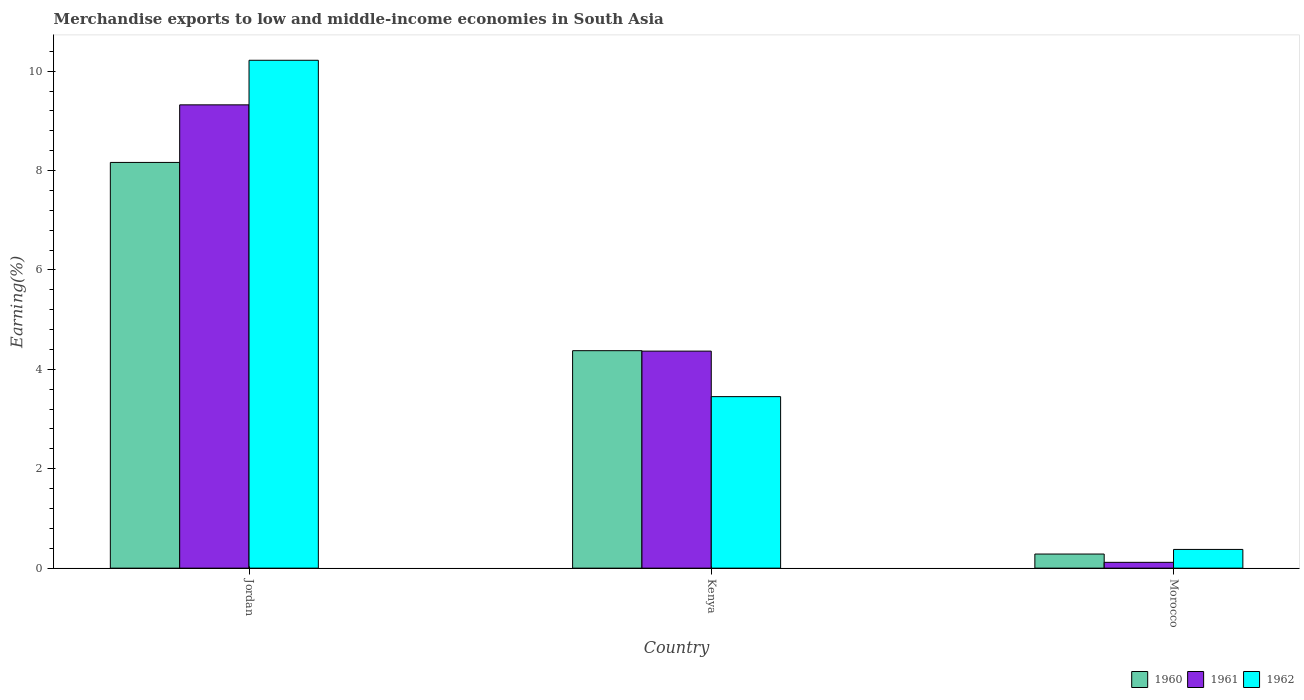How many bars are there on the 1st tick from the right?
Offer a very short reply. 3. What is the label of the 2nd group of bars from the left?
Offer a terse response. Kenya. In how many cases, is the number of bars for a given country not equal to the number of legend labels?
Keep it short and to the point. 0. What is the percentage of amount earned from merchandise exports in 1961 in Jordan?
Give a very brief answer. 9.32. Across all countries, what is the maximum percentage of amount earned from merchandise exports in 1962?
Your answer should be very brief. 10.22. Across all countries, what is the minimum percentage of amount earned from merchandise exports in 1961?
Your answer should be compact. 0.12. In which country was the percentage of amount earned from merchandise exports in 1962 maximum?
Your answer should be very brief. Jordan. In which country was the percentage of amount earned from merchandise exports in 1961 minimum?
Ensure brevity in your answer.  Morocco. What is the total percentage of amount earned from merchandise exports in 1961 in the graph?
Ensure brevity in your answer.  13.81. What is the difference between the percentage of amount earned from merchandise exports in 1961 in Kenya and that in Morocco?
Your response must be concise. 4.25. What is the difference between the percentage of amount earned from merchandise exports in 1960 in Jordan and the percentage of amount earned from merchandise exports in 1961 in Kenya?
Keep it short and to the point. 3.8. What is the average percentage of amount earned from merchandise exports in 1962 per country?
Provide a succinct answer. 4.68. What is the difference between the percentage of amount earned from merchandise exports of/in 1961 and percentage of amount earned from merchandise exports of/in 1962 in Jordan?
Keep it short and to the point. -0.9. What is the ratio of the percentage of amount earned from merchandise exports in 1962 in Jordan to that in Kenya?
Your answer should be compact. 2.96. Is the difference between the percentage of amount earned from merchandise exports in 1961 in Jordan and Morocco greater than the difference between the percentage of amount earned from merchandise exports in 1962 in Jordan and Morocco?
Your answer should be compact. No. What is the difference between the highest and the second highest percentage of amount earned from merchandise exports in 1961?
Give a very brief answer. -9.21. What is the difference between the highest and the lowest percentage of amount earned from merchandise exports in 1961?
Provide a succinct answer. 9.21. In how many countries, is the percentage of amount earned from merchandise exports in 1960 greater than the average percentage of amount earned from merchandise exports in 1960 taken over all countries?
Your answer should be compact. 2. What does the 1st bar from the left in Jordan represents?
Provide a short and direct response. 1960. Is it the case that in every country, the sum of the percentage of amount earned from merchandise exports in 1962 and percentage of amount earned from merchandise exports in 1960 is greater than the percentage of amount earned from merchandise exports in 1961?
Make the answer very short. Yes. Are the values on the major ticks of Y-axis written in scientific E-notation?
Ensure brevity in your answer.  No. What is the title of the graph?
Give a very brief answer. Merchandise exports to low and middle-income economies in South Asia. Does "1966" appear as one of the legend labels in the graph?
Keep it short and to the point. No. What is the label or title of the Y-axis?
Your response must be concise. Earning(%). What is the Earning(%) in 1960 in Jordan?
Your answer should be very brief. 8.16. What is the Earning(%) of 1961 in Jordan?
Offer a very short reply. 9.32. What is the Earning(%) of 1962 in Jordan?
Provide a short and direct response. 10.22. What is the Earning(%) in 1960 in Kenya?
Your answer should be compact. 4.38. What is the Earning(%) in 1961 in Kenya?
Provide a succinct answer. 4.37. What is the Earning(%) of 1962 in Kenya?
Your response must be concise. 3.45. What is the Earning(%) in 1960 in Morocco?
Make the answer very short. 0.28. What is the Earning(%) in 1961 in Morocco?
Provide a succinct answer. 0.12. What is the Earning(%) in 1962 in Morocco?
Make the answer very short. 0.38. Across all countries, what is the maximum Earning(%) in 1960?
Provide a succinct answer. 8.16. Across all countries, what is the maximum Earning(%) in 1961?
Your answer should be very brief. 9.32. Across all countries, what is the maximum Earning(%) in 1962?
Your answer should be very brief. 10.22. Across all countries, what is the minimum Earning(%) of 1960?
Keep it short and to the point. 0.28. Across all countries, what is the minimum Earning(%) in 1961?
Your response must be concise. 0.12. Across all countries, what is the minimum Earning(%) of 1962?
Provide a short and direct response. 0.38. What is the total Earning(%) in 1960 in the graph?
Keep it short and to the point. 12.82. What is the total Earning(%) of 1961 in the graph?
Give a very brief answer. 13.81. What is the total Earning(%) of 1962 in the graph?
Provide a short and direct response. 14.05. What is the difference between the Earning(%) in 1960 in Jordan and that in Kenya?
Provide a short and direct response. 3.79. What is the difference between the Earning(%) of 1961 in Jordan and that in Kenya?
Your response must be concise. 4.96. What is the difference between the Earning(%) in 1962 in Jordan and that in Kenya?
Keep it short and to the point. 6.77. What is the difference between the Earning(%) in 1960 in Jordan and that in Morocco?
Your answer should be very brief. 7.88. What is the difference between the Earning(%) in 1961 in Jordan and that in Morocco?
Give a very brief answer. 9.21. What is the difference between the Earning(%) of 1962 in Jordan and that in Morocco?
Offer a very short reply. 9.84. What is the difference between the Earning(%) of 1960 in Kenya and that in Morocco?
Offer a very short reply. 4.09. What is the difference between the Earning(%) of 1961 in Kenya and that in Morocco?
Offer a very short reply. 4.25. What is the difference between the Earning(%) in 1962 in Kenya and that in Morocco?
Offer a terse response. 3.07. What is the difference between the Earning(%) of 1960 in Jordan and the Earning(%) of 1961 in Kenya?
Your response must be concise. 3.8. What is the difference between the Earning(%) of 1960 in Jordan and the Earning(%) of 1962 in Kenya?
Your answer should be very brief. 4.71. What is the difference between the Earning(%) of 1961 in Jordan and the Earning(%) of 1962 in Kenya?
Give a very brief answer. 5.87. What is the difference between the Earning(%) of 1960 in Jordan and the Earning(%) of 1961 in Morocco?
Offer a terse response. 8.05. What is the difference between the Earning(%) in 1960 in Jordan and the Earning(%) in 1962 in Morocco?
Offer a terse response. 7.79. What is the difference between the Earning(%) in 1961 in Jordan and the Earning(%) in 1962 in Morocco?
Your answer should be compact. 8.95. What is the difference between the Earning(%) of 1960 in Kenya and the Earning(%) of 1961 in Morocco?
Make the answer very short. 4.26. What is the difference between the Earning(%) of 1960 in Kenya and the Earning(%) of 1962 in Morocco?
Your answer should be compact. 4. What is the difference between the Earning(%) in 1961 in Kenya and the Earning(%) in 1962 in Morocco?
Offer a terse response. 3.99. What is the average Earning(%) of 1960 per country?
Offer a very short reply. 4.27. What is the average Earning(%) in 1961 per country?
Your answer should be very brief. 4.6. What is the average Earning(%) of 1962 per country?
Ensure brevity in your answer.  4.68. What is the difference between the Earning(%) in 1960 and Earning(%) in 1961 in Jordan?
Provide a short and direct response. -1.16. What is the difference between the Earning(%) of 1960 and Earning(%) of 1962 in Jordan?
Your answer should be very brief. -2.06. What is the difference between the Earning(%) of 1961 and Earning(%) of 1962 in Jordan?
Ensure brevity in your answer.  -0.9. What is the difference between the Earning(%) in 1960 and Earning(%) in 1961 in Kenya?
Your answer should be compact. 0.01. What is the difference between the Earning(%) of 1960 and Earning(%) of 1962 in Kenya?
Keep it short and to the point. 0.92. What is the difference between the Earning(%) of 1961 and Earning(%) of 1962 in Kenya?
Your answer should be very brief. 0.92. What is the difference between the Earning(%) in 1960 and Earning(%) in 1961 in Morocco?
Offer a very short reply. 0.17. What is the difference between the Earning(%) in 1960 and Earning(%) in 1962 in Morocco?
Offer a terse response. -0.09. What is the difference between the Earning(%) of 1961 and Earning(%) of 1962 in Morocco?
Make the answer very short. -0.26. What is the ratio of the Earning(%) in 1960 in Jordan to that in Kenya?
Your answer should be compact. 1.87. What is the ratio of the Earning(%) of 1961 in Jordan to that in Kenya?
Give a very brief answer. 2.13. What is the ratio of the Earning(%) in 1962 in Jordan to that in Kenya?
Offer a very short reply. 2.96. What is the ratio of the Earning(%) of 1960 in Jordan to that in Morocco?
Ensure brevity in your answer.  28.77. What is the ratio of the Earning(%) of 1961 in Jordan to that in Morocco?
Your response must be concise. 79.68. What is the ratio of the Earning(%) of 1962 in Jordan to that in Morocco?
Your response must be concise. 27.14. What is the ratio of the Earning(%) of 1960 in Kenya to that in Morocco?
Offer a very short reply. 15.42. What is the ratio of the Earning(%) of 1961 in Kenya to that in Morocco?
Keep it short and to the point. 37.33. What is the ratio of the Earning(%) of 1962 in Kenya to that in Morocco?
Make the answer very short. 9.17. What is the difference between the highest and the second highest Earning(%) of 1960?
Your answer should be compact. 3.79. What is the difference between the highest and the second highest Earning(%) in 1961?
Offer a very short reply. 4.96. What is the difference between the highest and the second highest Earning(%) in 1962?
Give a very brief answer. 6.77. What is the difference between the highest and the lowest Earning(%) of 1960?
Offer a very short reply. 7.88. What is the difference between the highest and the lowest Earning(%) in 1961?
Provide a succinct answer. 9.21. What is the difference between the highest and the lowest Earning(%) in 1962?
Offer a terse response. 9.84. 